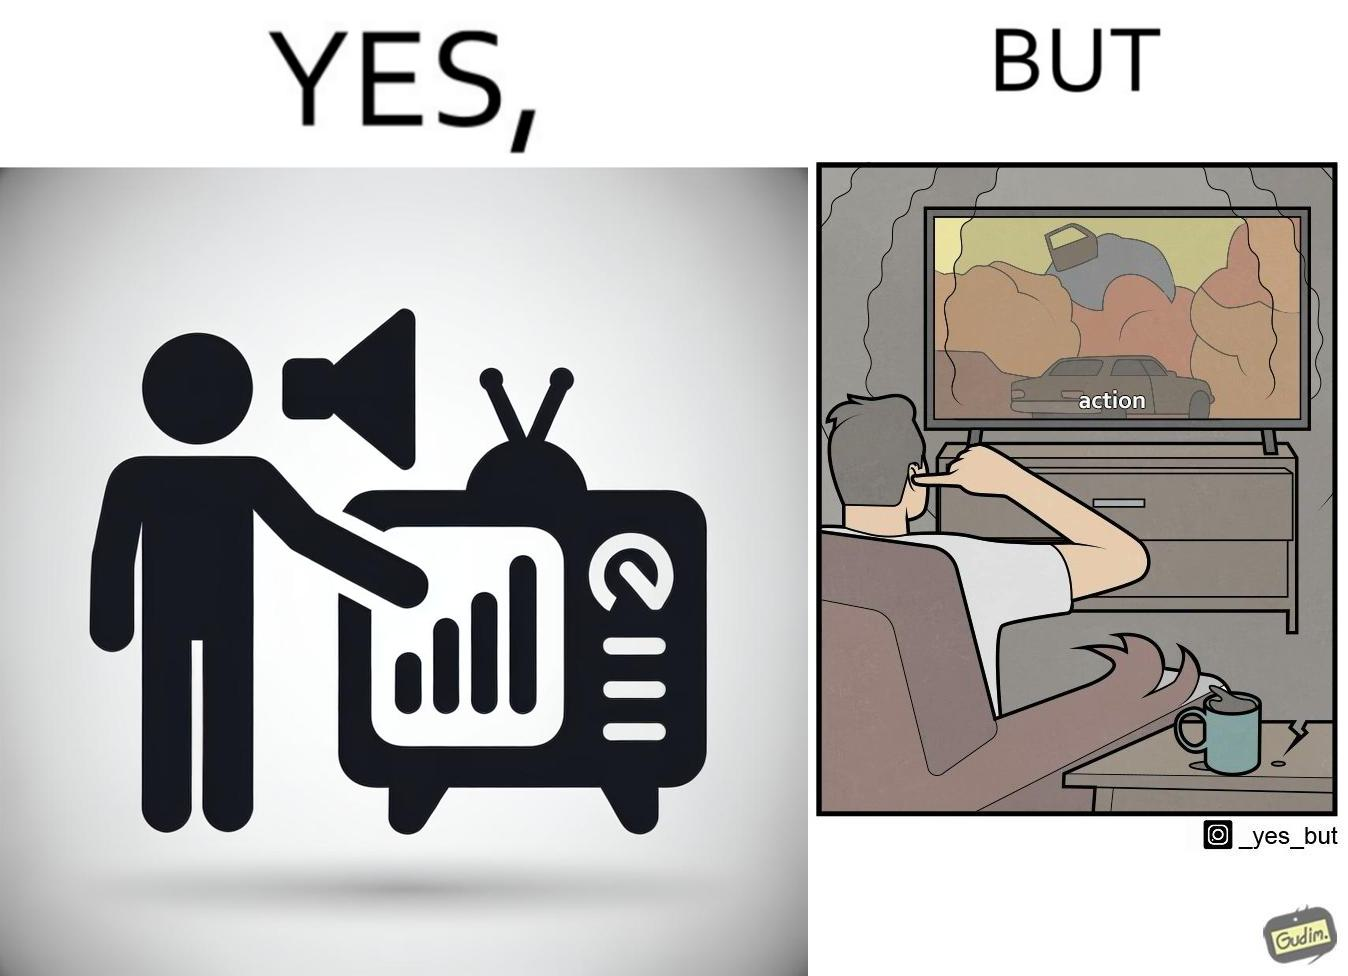Is there satirical content in this image? Yes, this image is satirical. 